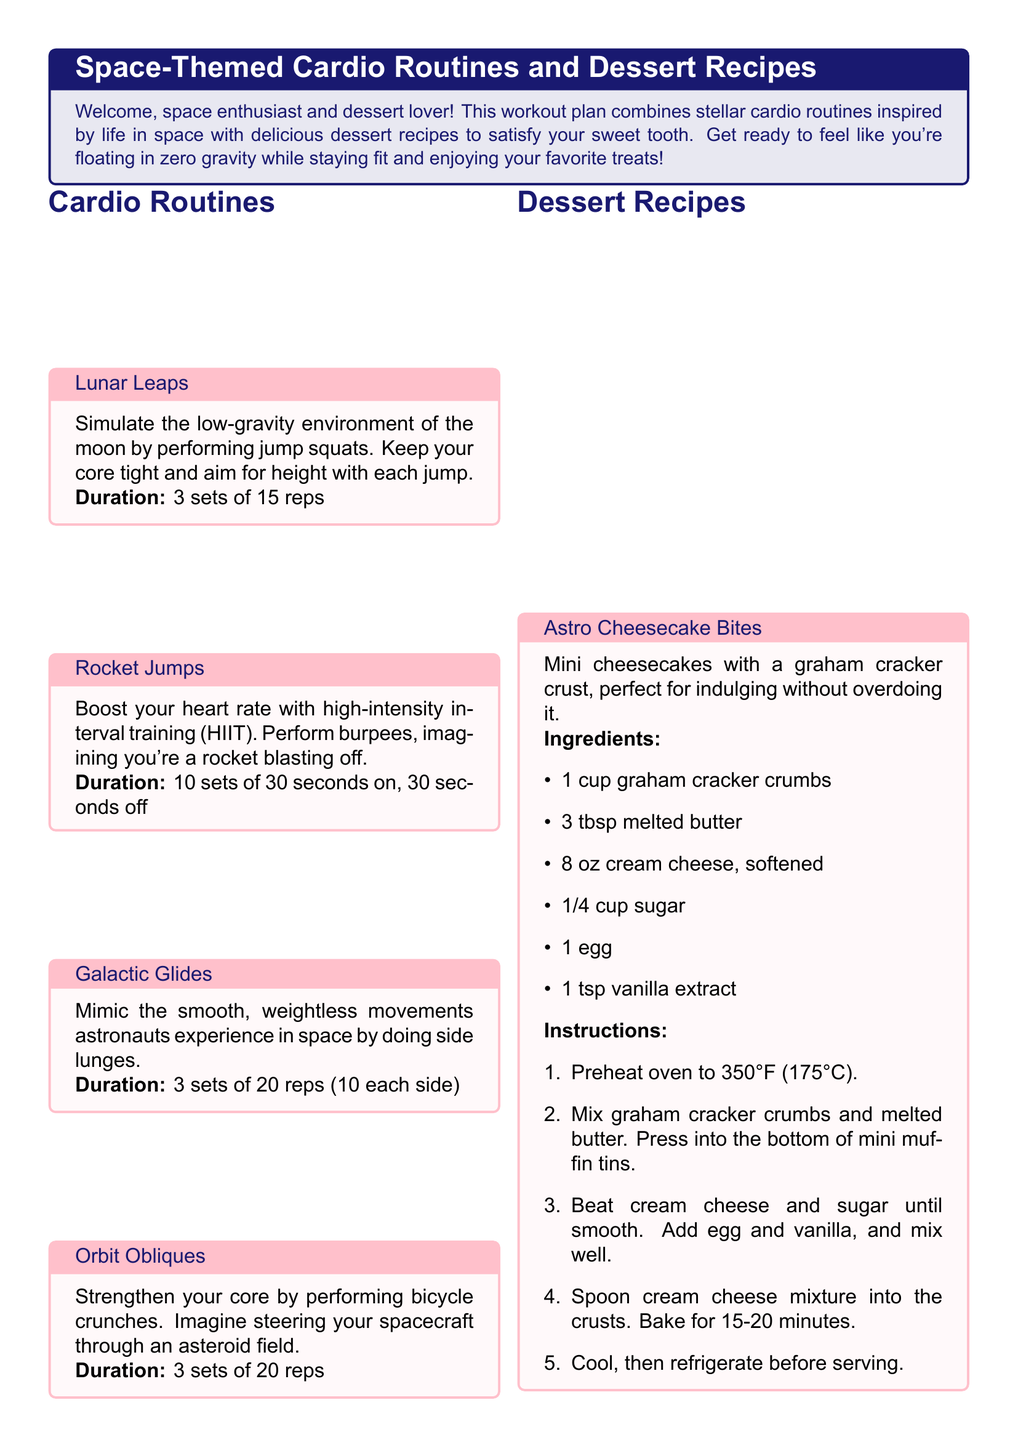What is the total number of cardio routines listed? The document lists four distinct cardio routines under the Cardio Routines section.
Answer: 4 What is the duration of Rocket Jumps? The duration for Rocket Jumps is specified as 10 sets of 30 seconds on, 30 seconds off.
Answer: 10 sets of 30 seconds on, 30 seconds off How many ingredients are needed for Zero-G Chocolate Mousse? The Zero-G Chocolate Mousse recipe includes four ingredients as mentioned in the list.
Answer: 4 What type of dessert is Astro Cheesecake Bites? Astro Cheesecake Bites are described as mini cheesecakes with a graham cracker crust.
Answer: Mini cheesecakes What physical movement does Galactic Glides simulate? Galactic Glides simulate the smooth, weightless movements astronauts experience in space.
Answer: Smooth, weightless movements How long should you bake the Astro Cheesecake Bites? The baking time for Astro Cheesecake Bites is specified as 15-20 minutes.
Answer: 15-20 minutes What exercise is performed to strengthen the core in the document? The exercise performed to strengthen the core is bicycle crunches.
Answer: Bicycle crunches How many side lunges are recommended in Galactic Glides? The document recommends performing 20 side lunges, which means 10 on each side.
Answer: 20 reps (10 each side) 